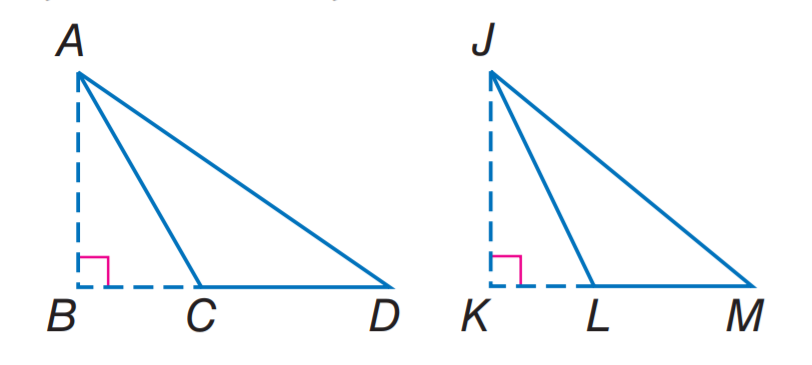Answer the mathemtical geometry problem and directly provide the correct option letter.
Question: If A B and J K are altitudes, \triangle D A C \sim \triangle M J L, A B = 9, A D = 4 x - 8, J K = 21, and J M = 5 x + 3, find x.
Choices: A: 4 B: 5 C: 8 D: 9 B 